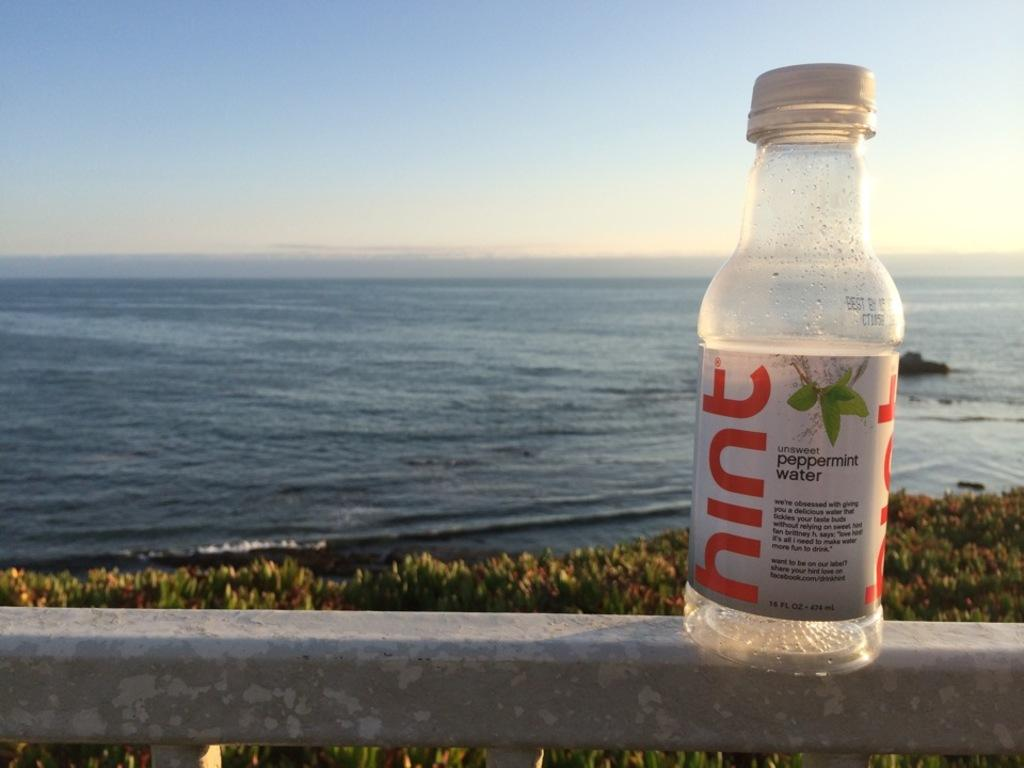<image>
Summarize the visual content of the image. A bottle of a drink called Hint sits on a fence near the ocean. 